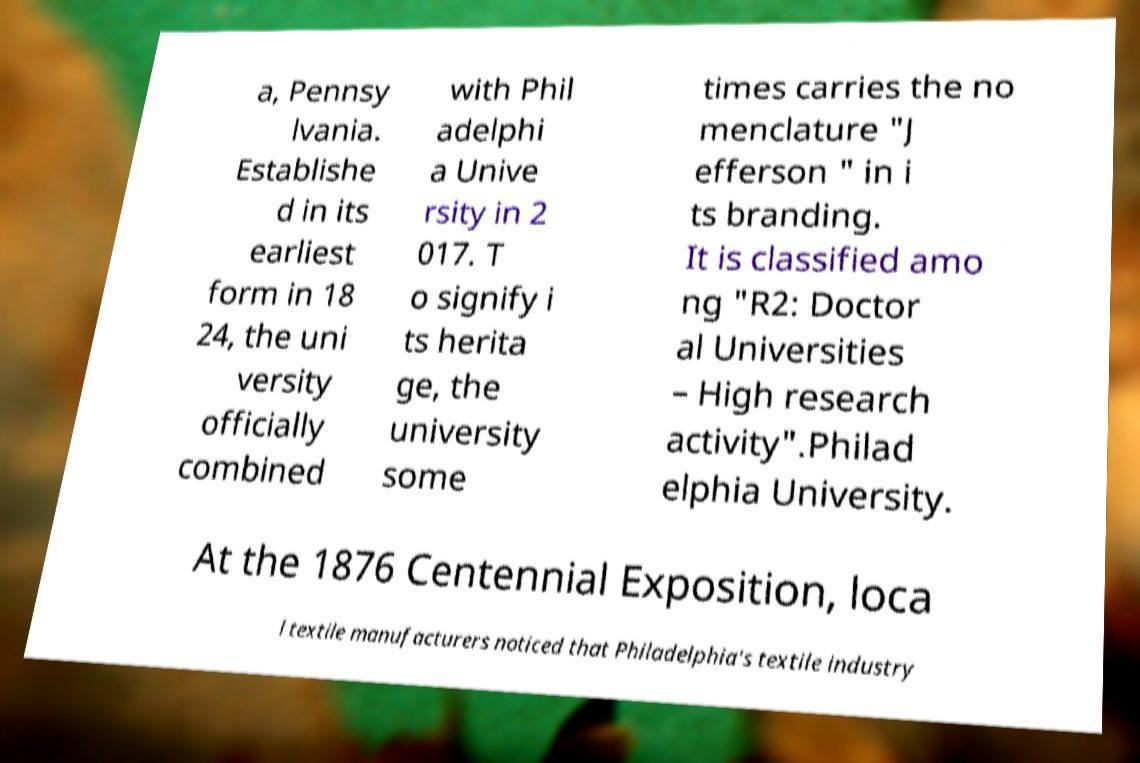Please read and relay the text visible in this image. What does it say? a, Pennsy lvania. Establishe d in its earliest form in 18 24, the uni versity officially combined with Phil adelphi a Unive rsity in 2 017. T o signify i ts herita ge, the university some times carries the no menclature "J efferson " in i ts branding. It is classified amo ng "R2: Doctor al Universities – High research activity".Philad elphia University. At the 1876 Centennial Exposition, loca l textile manufacturers noticed that Philadelphia's textile industry 